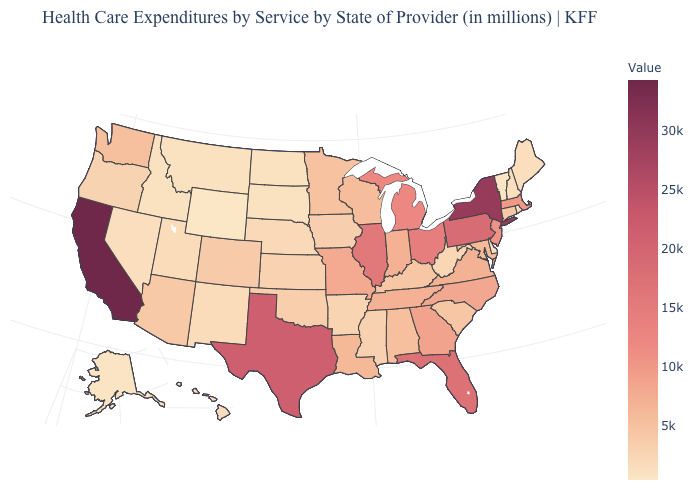Does the map have missing data?
Be succinct. No. Which states have the highest value in the USA?
Answer briefly. California. Among the states that border Georgia , which have the highest value?
Be succinct. Florida. Does Florida have the highest value in the USA?
Quick response, please. No. Which states have the highest value in the USA?
Short answer required. California. Does Wisconsin have a higher value than Texas?
Short answer required. No. Among the states that border Florida , which have the lowest value?
Be succinct. Alabama. Among the states that border Oregon , does California have the lowest value?
Short answer required. No. 